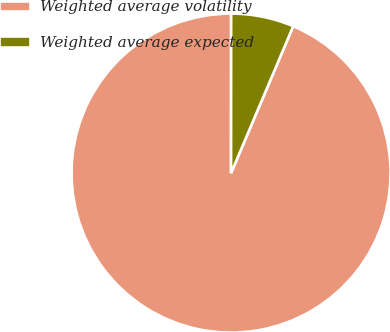Convert chart to OTSL. <chart><loc_0><loc_0><loc_500><loc_500><pie_chart><fcel>Weighted average volatility<fcel>Weighted average expected<nl><fcel>93.64%<fcel>6.36%<nl></chart> 